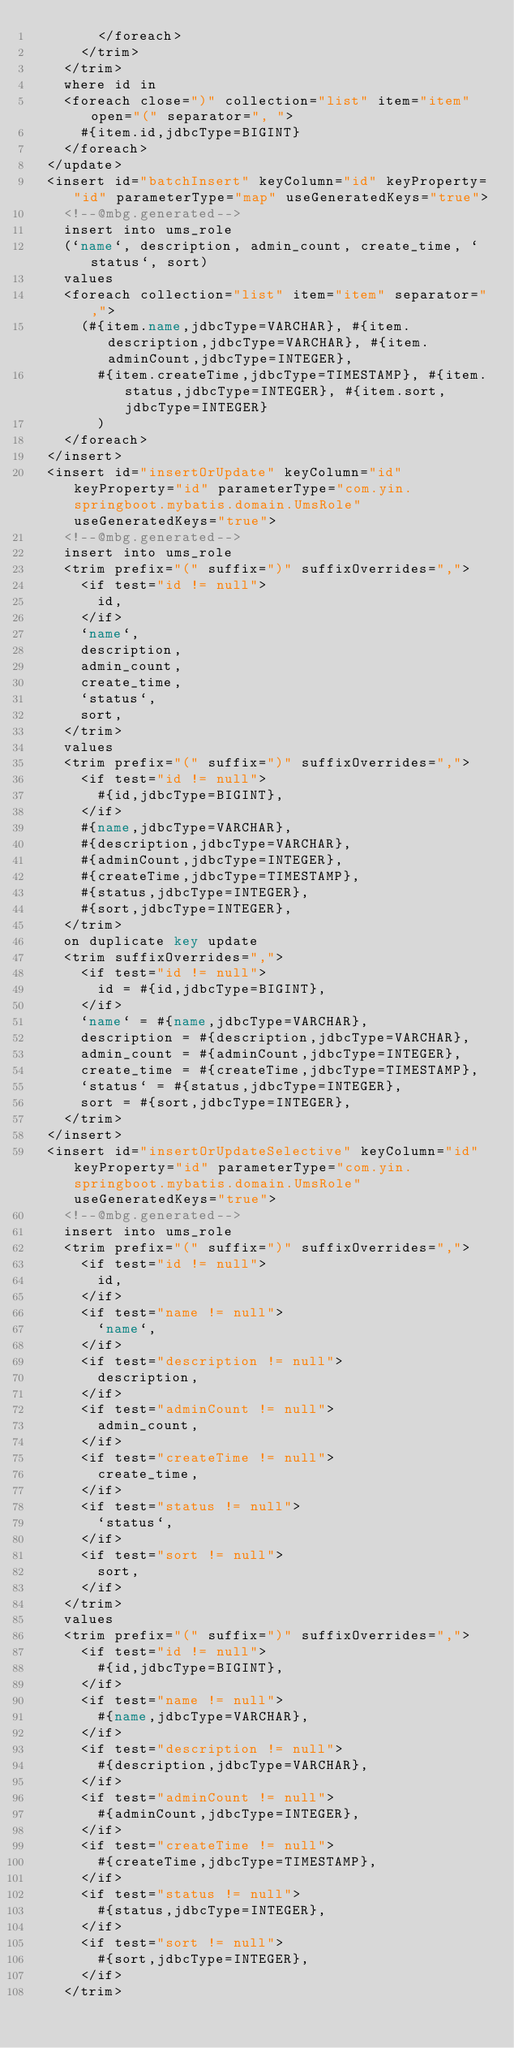<code> <loc_0><loc_0><loc_500><loc_500><_XML_>        </foreach>
      </trim>
    </trim>
    where id in
    <foreach close=")" collection="list" item="item" open="(" separator=", ">
      #{item.id,jdbcType=BIGINT}
    </foreach>
  </update>
  <insert id="batchInsert" keyColumn="id" keyProperty="id" parameterType="map" useGeneratedKeys="true">
    <!--@mbg.generated-->
    insert into ums_role
    (`name`, description, admin_count, create_time, `status`, sort)
    values
    <foreach collection="list" item="item" separator=",">
      (#{item.name,jdbcType=VARCHAR}, #{item.description,jdbcType=VARCHAR}, #{item.adminCount,jdbcType=INTEGER}, 
        #{item.createTime,jdbcType=TIMESTAMP}, #{item.status,jdbcType=INTEGER}, #{item.sort,jdbcType=INTEGER}
        )
    </foreach>
  </insert>
  <insert id="insertOrUpdate" keyColumn="id" keyProperty="id" parameterType="com.yin.springboot.mybatis.domain.UmsRole" useGeneratedKeys="true">
    <!--@mbg.generated-->
    insert into ums_role
    <trim prefix="(" suffix=")" suffixOverrides=",">
      <if test="id != null">
        id,
      </if>
      `name`,
      description,
      admin_count,
      create_time,
      `status`,
      sort,
    </trim>
    values
    <trim prefix="(" suffix=")" suffixOverrides=",">
      <if test="id != null">
        #{id,jdbcType=BIGINT},
      </if>
      #{name,jdbcType=VARCHAR},
      #{description,jdbcType=VARCHAR},
      #{adminCount,jdbcType=INTEGER},
      #{createTime,jdbcType=TIMESTAMP},
      #{status,jdbcType=INTEGER},
      #{sort,jdbcType=INTEGER},
    </trim>
    on duplicate key update 
    <trim suffixOverrides=",">
      <if test="id != null">
        id = #{id,jdbcType=BIGINT},
      </if>
      `name` = #{name,jdbcType=VARCHAR},
      description = #{description,jdbcType=VARCHAR},
      admin_count = #{adminCount,jdbcType=INTEGER},
      create_time = #{createTime,jdbcType=TIMESTAMP},
      `status` = #{status,jdbcType=INTEGER},
      sort = #{sort,jdbcType=INTEGER},
    </trim>
  </insert>
  <insert id="insertOrUpdateSelective" keyColumn="id" keyProperty="id" parameterType="com.yin.springboot.mybatis.domain.UmsRole" useGeneratedKeys="true">
    <!--@mbg.generated-->
    insert into ums_role
    <trim prefix="(" suffix=")" suffixOverrides=",">
      <if test="id != null">
        id,
      </if>
      <if test="name != null">
        `name`,
      </if>
      <if test="description != null">
        description,
      </if>
      <if test="adminCount != null">
        admin_count,
      </if>
      <if test="createTime != null">
        create_time,
      </if>
      <if test="status != null">
        `status`,
      </if>
      <if test="sort != null">
        sort,
      </if>
    </trim>
    values
    <trim prefix="(" suffix=")" suffixOverrides=",">
      <if test="id != null">
        #{id,jdbcType=BIGINT},
      </if>
      <if test="name != null">
        #{name,jdbcType=VARCHAR},
      </if>
      <if test="description != null">
        #{description,jdbcType=VARCHAR},
      </if>
      <if test="adminCount != null">
        #{adminCount,jdbcType=INTEGER},
      </if>
      <if test="createTime != null">
        #{createTime,jdbcType=TIMESTAMP},
      </if>
      <if test="status != null">
        #{status,jdbcType=INTEGER},
      </if>
      <if test="sort != null">
        #{sort,jdbcType=INTEGER},
      </if>
    </trim></code> 